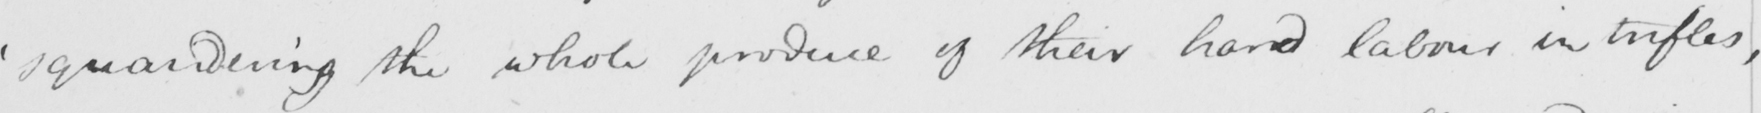Can you tell me what this handwritten text says? ' squandering the whole produce of their hard labour in trifles , 